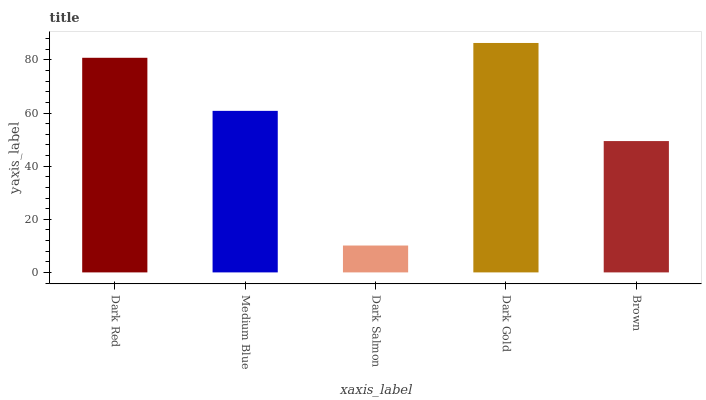Is Dark Salmon the minimum?
Answer yes or no. Yes. Is Dark Gold the maximum?
Answer yes or no. Yes. Is Medium Blue the minimum?
Answer yes or no. No. Is Medium Blue the maximum?
Answer yes or no. No. Is Dark Red greater than Medium Blue?
Answer yes or no. Yes. Is Medium Blue less than Dark Red?
Answer yes or no. Yes. Is Medium Blue greater than Dark Red?
Answer yes or no. No. Is Dark Red less than Medium Blue?
Answer yes or no. No. Is Medium Blue the high median?
Answer yes or no. Yes. Is Medium Blue the low median?
Answer yes or no. Yes. Is Dark Red the high median?
Answer yes or no. No. Is Brown the low median?
Answer yes or no. No. 